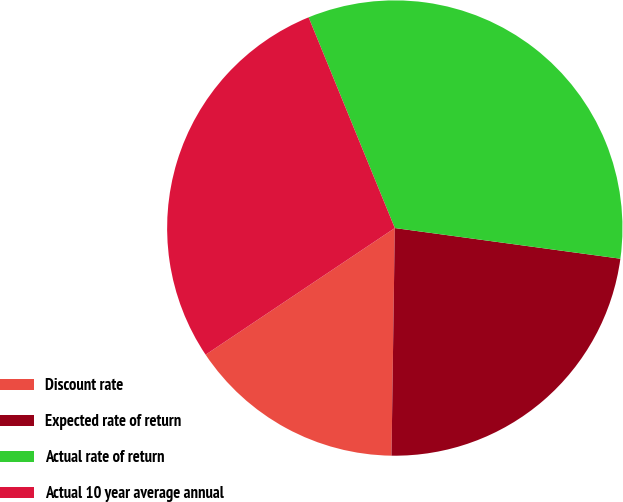Convert chart to OTSL. <chart><loc_0><loc_0><loc_500><loc_500><pie_chart><fcel>Discount rate<fcel>Expected rate of return<fcel>Actual rate of return<fcel>Actual 10 year average annual<nl><fcel>15.38%<fcel>23.08%<fcel>33.33%<fcel>28.21%<nl></chart> 